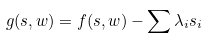Convert formula to latex. <formula><loc_0><loc_0><loc_500><loc_500>g ( s , w ) = f ( s , w ) - \sum \lambda _ { i } s _ { i }</formula> 